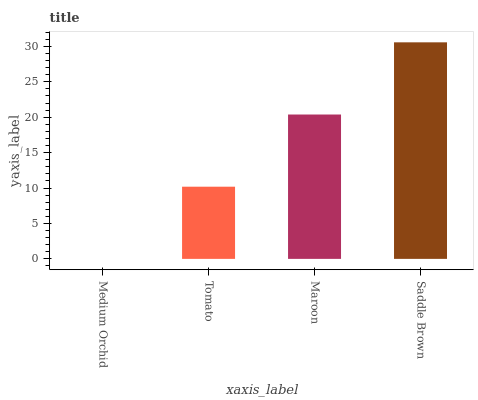Is Medium Orchid the minimum?
Answer yes or no. Yes. Is Saddle Brown the maximum?
Answer yes or no. Yes. Is Tomato the minimum?
Answer yes or no. No. Is Tomato the maximum?
Answer yes or no. No. Is Tomato greater than Medium Orchid?
Answer yes or no. Yes. Is Medium Orchid less than Tomato?
Answer yes or no. Yes. Is Medium Orchid greater than Tomato?
Answer yes or no. No. Is Tomato less than Medium Orchid?
Answer yes or no. No. Is Maroon the high median?
Answer yes or no. Yes. Is Tomato the low median?
Answer yes or no. Yes. Is Tomato the high median?
Answer yes or no. No. Is Medium Orchid the low median?
Answer yes or no. No. 